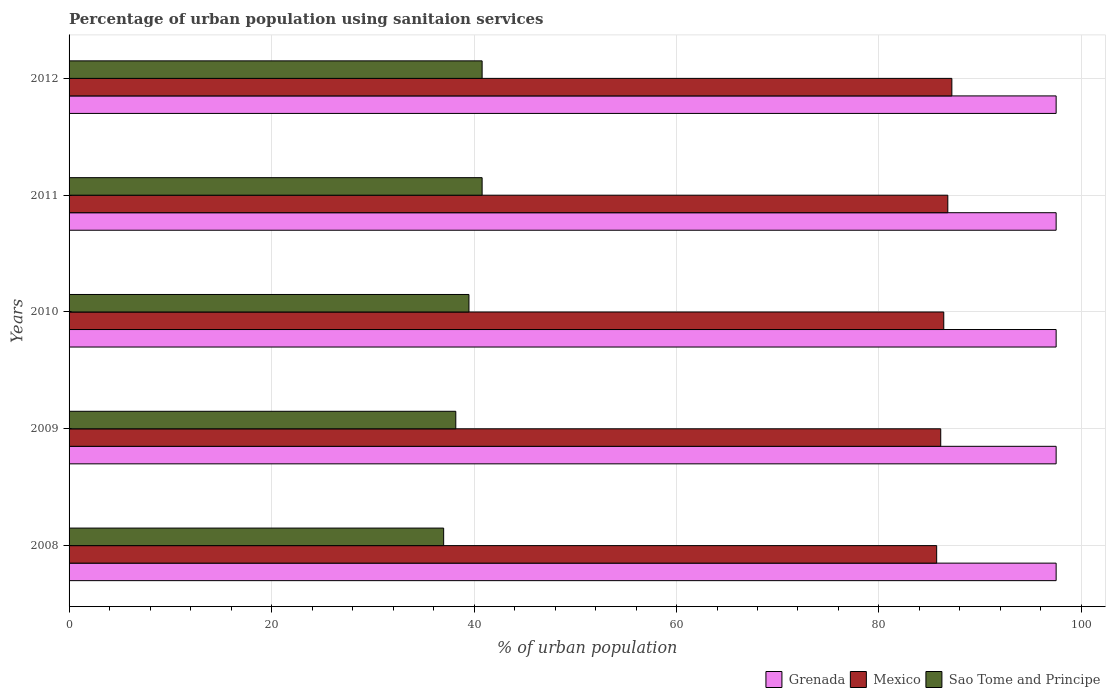How many groups of bars are there?
Your answer should be compact. 5. Are the number of bars on each tick of the Y-axis equal?
Make the answer very short. Yes. How many bars are there on the 1st tick from the top?
Provide a succinct answer. 3. What is the percentage of urban population using sanitaion services in Grenada in 2008?
Provide a short and direct response. 97.5. Across all years, what is the maximum percentage of urban population using sanitaion services in Sao Tome and Principe?
Your answer should be compact. 40.8. In which year was the percentage of urban population using sanitaion services in Sao Tome and Principe maximum?
Provide a short and direct response. 2011. In which year was the percentage of urban population using sanitaion services in Sao Tome and Principe minimum?
Provide a succinct answer. 2008. What is the total percentage of urban population using sanitaion services in Mexico in the graph?
Your answer should be compact. 432.2. What is the difference between the percentage of urban population using sanitaion services in Grenada in 2008 and that in 2011?
Give a very brief answer. 0. What is the difference between the percentage of urban population using sanitaion services in Sao Tome and Principe in 2010 and the percentage of urban population using sanitaion services in Grenada in 2011?
Keep it short and to the point. -58. What is the average percentage of urban population using sanitaion services in Grenada per year?
Keep it short and to the point. 97.5. In the year 2009, what is the difference between the percentage of urban population using sanitaion services in Sao Tome and Principe and percentage of urban population using sanitaion services in Mexico?
Offer a terse response. -47.9. What is the ratio of the percentage of urban population using sanitaion services in Sao Tome and Principe in 2008 to that in 2011?
Offer a terse response. 0.91. What is the difference between the highest and the lowest percentage of urban population using sanitaion services in Mexico?
Provide a succinct answer. 1.5. In how many years, is the percentage of urban population using sanitaion services in Mexico greater than the average percentage of urban population using sanitaion services in Mexico taken over all years?
Ensure brevity in your answer.  2. Is the sum of the percentage of urban population using sanitaion services in Mexico in 2009 and 2011 greater than the maximum percentage of urban population using sanitaion services in Grenada across all years?
Provide a short and direct response. Yes. What does the 1st bar from the top in 2010 represents?
Provide a succinct answer. Sao Tome and Principe. What does the 1st bar from the bottom in 2008 represents?
Offer a terse response. Grenada. Is it the case that in every year, the sum of the percentage of urban population using sanitaion services in Mexico and percentage of urban population using sanitaion services in Grenada is greater than the percentage of urban population using sanitaion services in Sao Tome and Principe?
Your response must be concise. Yes. How many bars are there?
Your response must be concise. 15. How many years are there in the graph?
Give a very brief answer. 5. Are the values on the major ticks of X-axis written in scientific E-notation?
Keep it short and to the point. No. Does the graph contain grids?
Make the answer very short. Yes. Where does the legend appear in the graph?
Give a very brief answer. Bottom right. How are the legend labels stacked?
Ensure brevity in your answer.  Horizontal. What is the title of the graph?
Provide a short and direct response. Percentage of urban population using sanitaion services. Does "Northern Mariana Islands" appear as one of the legend labels in the graph?
Provide a succinct answer. No. What is the label or title of the X-axis?
Offer a terse response. % of urban population. What is the label or title of the Y-axis?
Offer a terse response. Years. What is the % of urban population of Grenada in 2008?
Give a very brief answer. 97.5. What is the % of urban population of Mexico in 2008?
Offer a terse response. 85.7. What is the % of urban population in Grenada in 2009?
Your answer should be very brief. 97.5. What is the % of urban population in Mexico in 2009?
Your response must be concise. 86.1. What is the % of urban population of Sao Tome and Principe in 2009?
Offer a terse response. 38.2. What is the % of urban population of Grenada in 2010?
Provide a succinct answer. 97.5. What is the % of urban population in Mexico in 2010?
Provide a short and direct response. 86.4. What is the % of urban population of Sao Tome and Principe in 2010?
Offer a very short reply. 39.5. What is the % of urban population in Grenada in 2011?
Offer a very short reply. 97.5. What is the % of urban population in Mexico in 2011?
Make the answer very short. 86.8. What is the % of urban population in Sao Tome and Principe in 2011?
Provide a succinct answer. 40.8. What is the % of urban population of Grenada in 2012?
Your answer should be compact. 97.5. What is the % of urban population of Mexico in 2012?
Your answer should be very brief. 87.2. What is the % of urban population of Sao Tome and Principe in 2012?
Provide a short and direct response. 40.8. Across all years, what is the maximum % of urban population of Grenada?
Provide a succinct answer. 97.5. Across all years, what is the maximum % of urban population of Mexico?
Make the answer very short. 87.2. Across all years, what is the maximum % of urban population in Sao Tome and Principe?
Make the answer very short. 40.8. Across all years, what is the minimum % of urban population in Grenada?
Keep it short and to the point. 97.5. Across all years, what is the minimum % of urban population of Mexico?
Your answer should be very brief. 85.7. What is the total % of urban population of Grenada in the graph?
Give a very brief answer. 487.5. What is the total % of urban population of Mexico in the graph?
Make the answer very short. 432.2. What is the total % of urban population of Sao Tome and Principe in the graph?
Offer a very short reply. 196.3. What is the difference between the % of urban population in Grenada in 2008 and that in 2009?
Ensure brevity in your answer.  0. What is the difference between the % of urban population in Mexico in 2008 and that in 2009?
Offer a very short reply. -0.4. What is the difference between the % of urban population of Grenada in 2008 and that in 2010?
Offer a terse response. 0. What is the difference between the % of urban population in Grenada in 2008 and that in 2011?
Your answer should be very brief. 0. What is the difference between the % of urban population in Mexico in 2008 and that in 2012?
Keep it short and to the point. -1.5. What is the difference between the % of urban population in Sao Tome and Principe in 2008 and that in 2012?
Provide a short and direct response. -3.8. What is the difference between the % of urban population in Mexico in 2009 and that in 2010?
Keep it short and to the point. -0.3. What is the difference between the % of urban population in Sao Tome and Principe in 2009 and that in 2010?
Your response must be concise. -1.3. What is the difference between the % of urban population in Grenada in 2009 and that in 2011?
Your response must be concise. 0. What is the difference between the % of urban population of Mexico in 2009 and that in 2011?
Make the answer very short. -0.7. What is the difference between the % of urban population in Sao Tome and Principe in 2009 and that in 2011?
Your answer should be very brief. -2.6. What is the difference between the % of urban population in Sao Tome and Principe in 2009 and that in 2012?
Offer a terse response. -2.6. What is the difference between the % of urban population of Grenada in 2010 and that in 2011?
Your answer should be compact. 0. What is the difference between the % of urban population in Sao Tome and Principe in 2010 and that in 2011?
Your answer should be compact. -1.3. What is the difference between the % of urban population of Mexico in 2010 and that in 2012?
Your answer should be very brief. -0.8. What is the difference between the % of urban population of Sao Tome and Principe in 2010 and that in 2012?
Your answer should be compact. -1.3. What is the difference between the % of urban population in Sao Tome and Principe in 2011 and that in 2012?
Your answer should be compact. 0. What is the difference between the % of urban population in Grenada in 2008 and the % of urban population in Sao Tome and Principe in 2009?
Make the answer very short. 59.3. What is the difference between the % of urban population of Mexico in 2008 and the % of urban population of Sao Tome and Principe in 2009?
Your response must be concise. 47.5. What is the difference between the % of urban population of Mexico in 2008 and the % of urban population of Sao Tome and Principe in 2010?
Offer a very short reply. 46.2. What is the difference between the % of urban population in Grenada in 2008 and the % of urban population in Sao Tome and Principe in 2011?
Offer a very short reply. 56.7. What is the difference between the % of urban population in Mexico in 2008 and the % of urban population in Sao Tome and Principe in 2011?
Ensure brevity in your answer.  44.9. What is the difference between the % of urban population in Grenada in 2008 and the % of urban population in Sao Tome and Principe in 2012?
Make the answer very short. 56.7. What is the difference between the % of urban population of Mexico in 2008 and the % of urban population of Sao Tome and Principe in 2012?
Make the answer very short. 44.9. What is the difference between the % of urban population in Mexico in 2009 and the % of urban population in Sao Tome and Principe in 2010?
Provide a short and direct response. 46.6. What is the difference between the % of urban population of Grenada in 2009 and the % of urban population of Sao Tome and Principe in 2011?
Ensure brevity in your answer.  56.7. What is the difference between the % of urban population of Mexico in 2009 and the % of urban population of Sao Tome and Principe in 2011?
Provide a short and direct response. 45.3. What is the difference between the % of urban population of Grenada in 2009 and the % of urban population of Mexico in 2012?
Your response must be concise. 10.3. What is the difference between the % of urban population of Grenada in 2009 and the % of urban population of Sao Tome and Principe in 2012?
Keep it short and to the point. 56.7. What is the difference between the % of urban population in Mexico in 2009 and the % of urban population in Sao Tome and Principe in 2012?
Your answer should be compact. 45.3. What is the difference between the % of urban population of Grenada in 2010 and the % of urban population of Mexico in 2011?
Give a very brief answer. 10.7. What is the difference between the % of urban population of Grenada in 2010 and the % of urban population of Sao Tome and Principe in 2011?
Your answer should be compact. 56.7. What is the difference between the % of urban population in Mexico in 2010 and the % of urban population in Sao Tome and Principe in 2011?
Make the answer very short. 45.6. What is the difference between the % of urban population of Grenada in 2010 and the % of urban population of Mexico in 2012?
Give a very brief answer. 10.3. What is the difference between the % of urban population of Grenada in 2010 and the % of urban population of Sao Tome and Principe in 2012?
Provide a succinct answer. 56.7. What is the difference between the % of urban population in Mexico in 2010 and the % of urban population in Sao Tome and Principe in 2012?
Give a very brief answer. 45.6. What is the difference between the % of urban population in Grenada in 2011 and the % of urban population in Mexico in 2012?
Your answer should be very brief. 10.3. What is the difference between the % of urban population of Grenada in 2011 and the % of urban population of Sao Tome and Principe in 2012?
Your answer should be very brief. 56.7. What is the average % of urban population of Grenada per year?
Offer a very short reply. 97.5. What is the average % of urban population in Mexico per year?
Provide a succinct answer. 86.44. What is the average % of urban population in Sao Tome and Principe per year?
Ensure brevity in your answer.  39.26. In the year 2008, what is the difference between the % of urban population in Grenada and % of urban population in Sao Tome and Principe?
Your answer should be compact. 60.5. In the year 2008, what is the difference between the % of urban population in Mexico and % of urban population in Sao Tome and Principe?
Your answer should be very brief. 48.7. In the year 2009, what is the difference between the % of urban population of Grenada and % of urban population of Sao Tome and Principe?
Provide a short and direct response. 59.3. In the year 2009, what is the difference between the % of urban population of Mexico and % of urban population of Sao Tome and Principe?
Your response must be concise. 47.9. In the year 2010, what is the difference between the % of urban population in Grenada and % of urban population in Sao Tome and Principe?
Keep it short and to the point. 58. In the year 2010, what is the difference between the % of urban population in Mexico and % of urban population in Sao Tome and Principe?
Make the answer very short. 46.9. In the year 2011, what is the difference between the % of urban population in Grenada and % of urban population in Mexico?
Keep it short and to the point. 10.7. In the year 2011, what is the difference between the % of urban population in Grenada and % of urban population in Sao Tome and Principe?
Make the answer very short. 56.7. In the year 2011, what is the difference between the % of urban population in Mexico and % of urban population in Sao Tome and Principe?
Keep it short and to the point. 46. In the year 2012, what is the difference between the % of urban population of Grenada and % of urban population of Sao Tome and Principe?
Your answer should be very brief. 56.7. In the year 2012, what is the difference between the % of urban population of Mexico and % of urban population of Sao Tome and Principe?
Offer a very short reply. 46.4. What is the ratio of the % of urban population in Mexico in 2008 to that in 2009?
Ensure brevity in your answer.  1. What is the ratio of the % of urban population in Sao Tome and Principe in 2008 to that in 2009?
Give a very brief answer. 0.97. What is the ratio of the % of urban population in Sao Tome and Principe in 2008 to that in 2010?
Your answer should be compact. 0.94. What is the ratio of the % of urban population in Grenada in 2008 to that in 2011?
Your answer should be very brief. 1. What is the ratio of the % of urban population of Mexico in 2008 to that in 2011?
Offer a terse response. 0.99. What is the ratio of the % of urban population in Sao Tome and Principe in 2008 to that in 2011?
Your answer should be very brief. 0.91. What is the ratio of the % of urban population of Grenada in 2008 to that in 2012?
Offer a terse response. 1. What is the ratio of the % of urban population in Mexico in 2008 to that in 2012?
Give a very brief answer. 0.98. What is the ratio of the % of urban population in Sao Tome and Principe in 2008 to that in 2012?
Your response must be concise. 0.91. What is the ratio of the % of urban population of Grenada in 2009 to that in 2010?
Make the answer very short. 1. What is the ratio of the % of urban population in Sao Tome and Principe in 2009 to that in 2010?
Provide a succinct answer. 0.97. What is the ratio of the % of urban population in Grenada in 2009 to that in 2011?
Your answer should be very brief. 1. What is the ratio of the % of urban population in Mexico in 2009 to that in 2011?
Ensure brevity in your answer.  0.99. What is the ratio of the % of urban population of Sao Tome and Principe in 2009 to that in 2011?
Provide a short and direct response. 0.94. What is the ratio of the % of urban population of Grenada in 2009 to that in 2012?
Provide a short and direct response. 1. What is the ratio of the % of urban population of Mexico in 2009 to that in 2012?
Keep it short and to the point. 0.99. What is the ratio of the % of urban population in Sao Tome and Principe in 2009 to that in 2012?
Keep it short and to the point. 0.94. What is the ratio of the % of urban population in Mexico in 2010 to that in 2011?
Give a very brief answer. 1. What is the ratio of the % of urban population in Sao Tome and Principe in 2010 to that in 2011?
Give a very brief answer. 0.97. What is the ratio of the % of urban population in Grenada in 2010 to that in 2012?
Provide a short and direct response. 1. What is the ratio of the % of urban population in Mexico in 2010 to that in 2012?
Offer a very short reply. 0.99. What is the ratio of the % of urban population of Sao Tome and Principe in 2010 to that in 2012?
Offer a very short reply. 0.97. What is the ratio of the % of urban population of Mexico in 2011 to that in 2012?
Your response must be concise. 1. What is the difference between the highest and the second highest % of urban population of Grenada?
Give a very brief answer. 0. What is the difference between the highest and the second highest % of urban population in Mexico?
Your response must be concise. 0.4. What is the difference between the highest and the lowest % of urban population in Sao Tome and Principe?
Offer a terse response. 3.8. 